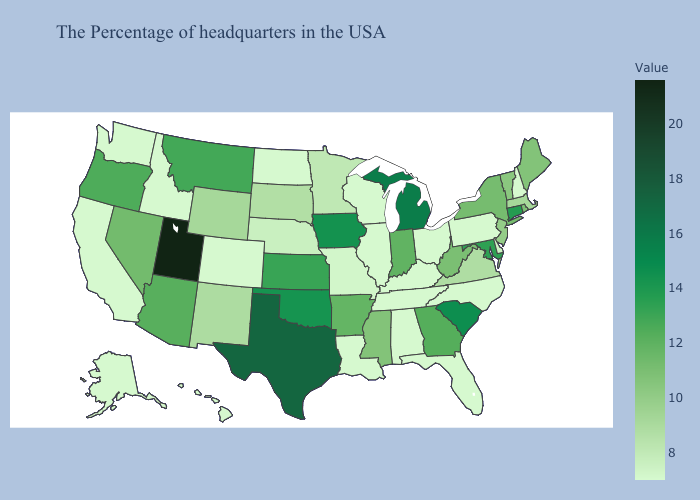Does Mississippi have the highest value in the USA?
Concise answer only. No. Among the states that border Arkansas , does Texas have the lowest value?
Concise answer only. No. Does North Dakota have the highest value in the MidWest?
Concise answer only. No. Does New York have the highest value in the Northeast?
Keep it brief. No. Which states hav the highest value in the West?
Short answer required. Utah. Among the states that border North Carolina , does South Carolina have the highest value?
Give a very brief answer. Yes. Among the states that border Wisconsin , which have the lowest value?
Give a very brief answer. Illinois. Does the map have missing data?
Write a very short answer. No. 